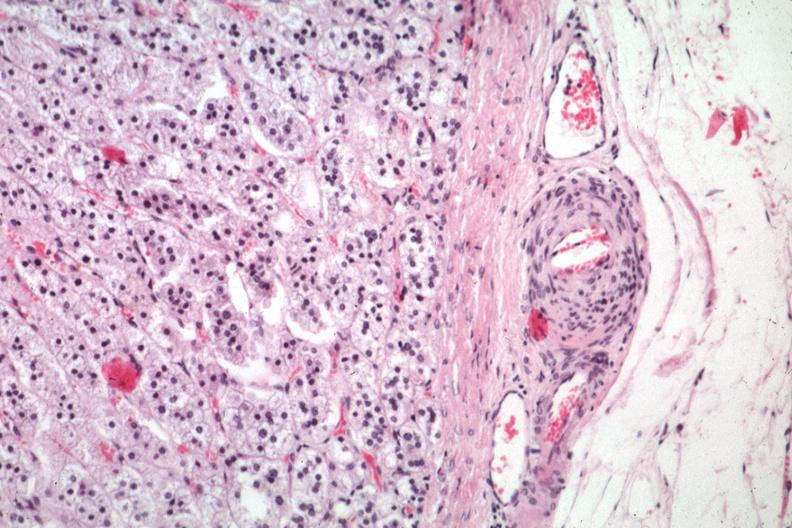what is present?
Answer the question using a single word or phrase. Endocrine 